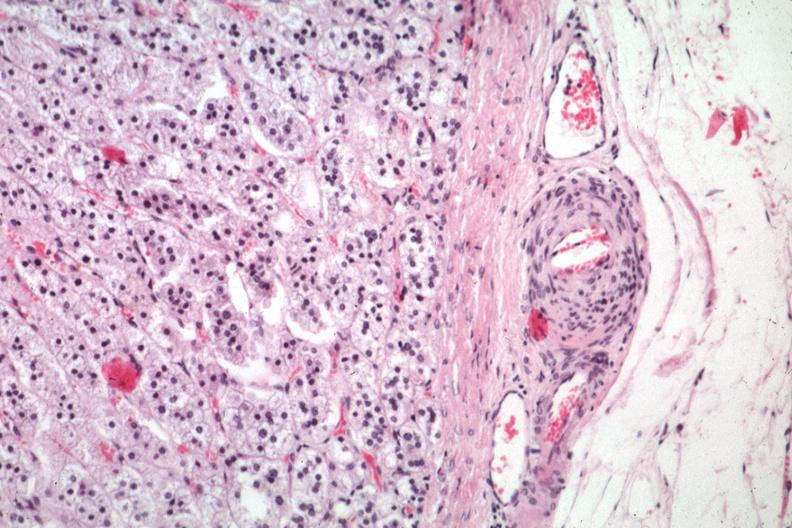what is present?
Answer the question using a single word or phrase. Endocrine 